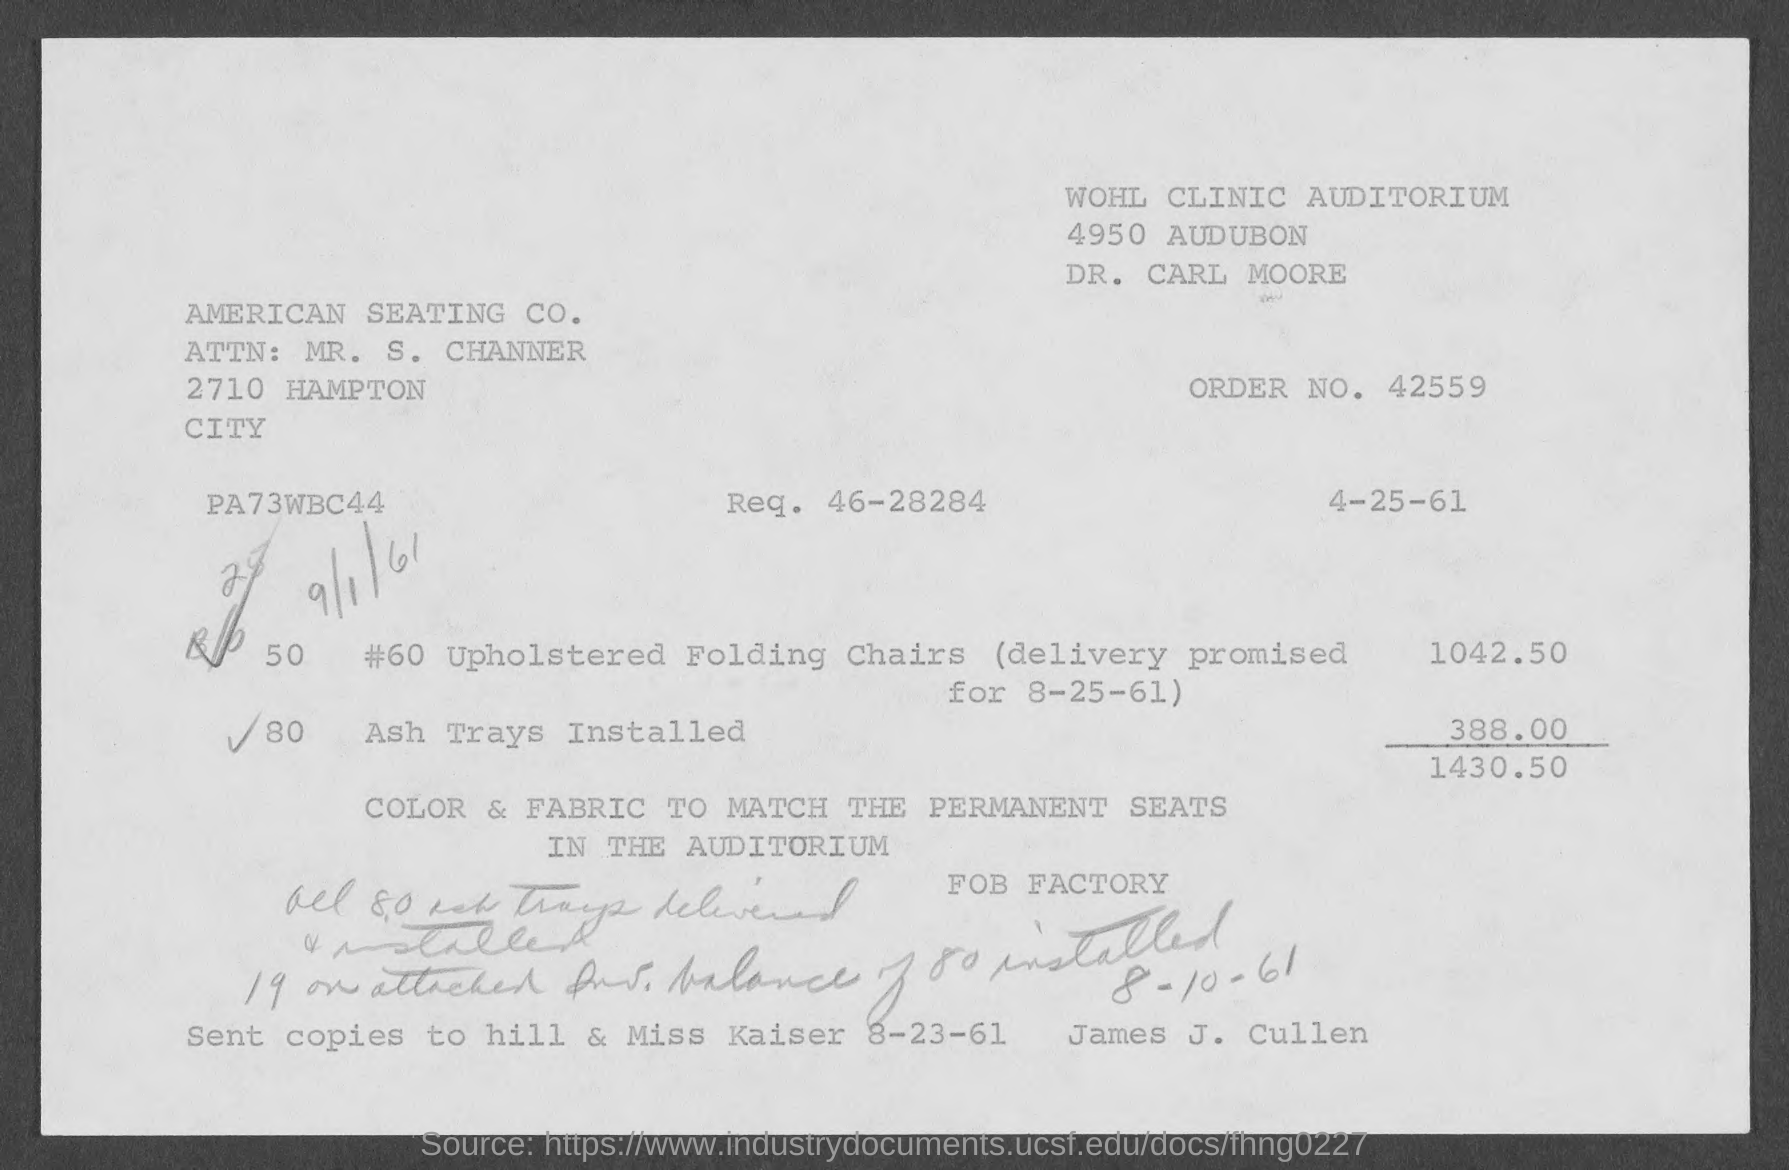What is the order no.?
Make the answer very short. 42559. What is req. no?
Offer a terse response. 46-28284. 